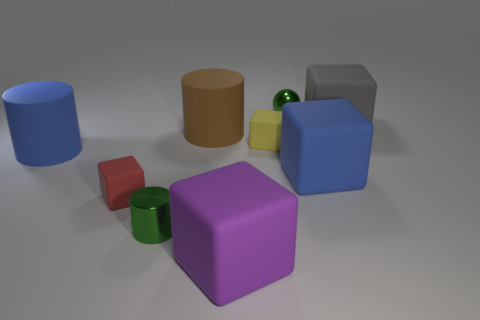What number of large gray objects are in front of the small green shiny object behind the large gray object?
Make the answer very short. 1. What number of things are either big cubes or big purple blocks?
Make the answer very short. 3. Is the purple object the same shape as the brown object?
Your response must be concise. No. What is the material of the green ball?
Your response must be concise. Metal. What number of things are both left of the purple rubber block and behind the blue cube?
Your answer should be very brief. 2. Is the blue rubber cylinder the same size as the brown cylinder?
Give a very brief answer. Yes. Do the blue thing in front of the blue cylinder and the large brown object have the same size?
Keep it short and to the point. Yes. The small thing that is behind the gray matte thing is what color?
Your answer should be very brief. Green. How many yellow matte things are there?
Make the answer very short. 1. What shape is the yellow thing that is made of the same material as the brown thing?
Keep it short and to the point. Cube. 